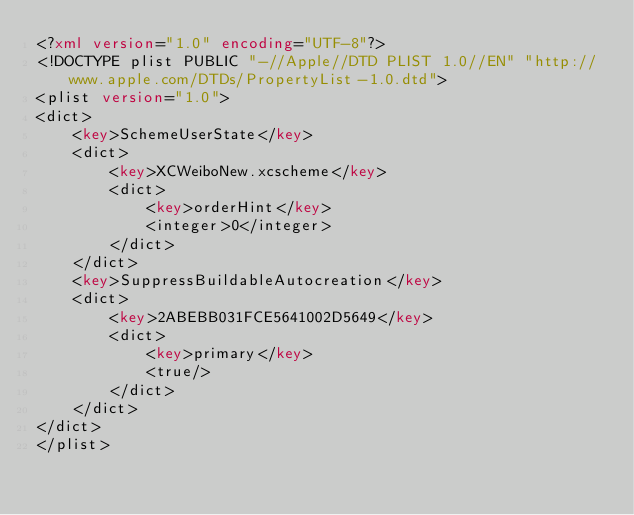<code> <loc_0><loc_0><loc_500><loc_500><_XML_><?xml version="1.0" encoding="UTF-8"?>
<!DOCTYPE plist PUBLIC "-//Apple//DTD PLIST 1.0//EN" "http://www.apple.com/DTDs/PropertyList-1.0.dtd">
<plist version="1.0">
<dict>
	<key>SchemeUserState</key>
	<dict>
		<key>XCWeiboNew.xcscheme</key>
		<dict>
			<key>orderHint</key>
			<integer>0</integer>
		</dict>
	</dict>
	<key>SuppressBuildableAutocreation</key>
	<dict>
		<key>2ABEBB031FCE5641002D5649</key>
		<dict>
			<key>primary</key>
			<true/>
		</dict>
	</dict>
</dict>
</plist>
</code> 